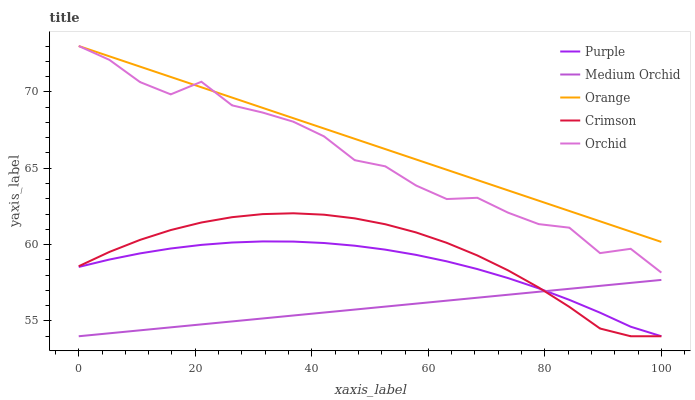Does Medium Orchid have the minimum area under the curve?
Answer yes or no. Yes. Does Orange have the maximum area under the curve?
Answer yes or no. Yes. Does Orange have the minimum area under the curve?
Answer yes or no. No. Does Medium Orchid have the maximum area under the curve?
Answer yes or no. No. Is Medium Orchid the smoothest?
Answer yes or no. Yes. Is Orchid the roughest?
Answer yes or no. Yes. Is Orange the smoothest?
Answer yes or no. No. Is Orange the roughest?
Answer yes or no. No. Does Purple have the lowest value?
Answer yes or no. Yes. Does Orange have the lowest value?
Answer yes or no. No. Does Orchid have the highest value?
Answer yes or no. Yes. Does Medium Orchid have the highest value?
Answer yes or no. No. Is Crimson less than Orange?
Answer yes or no. Yes. Is Orange greater than Purple?
Answer yes or no. Yes. Does Crimson intersect Medium Orchid?
Answer yes or no. Yes. Is Crimson less than Medium Orchid?
Answer yes or no. No. Is Crimson greater than Medium Orchid?
Answer yes or no. No. Does Crimson intersect Orange?
Answer yes or no. No. 